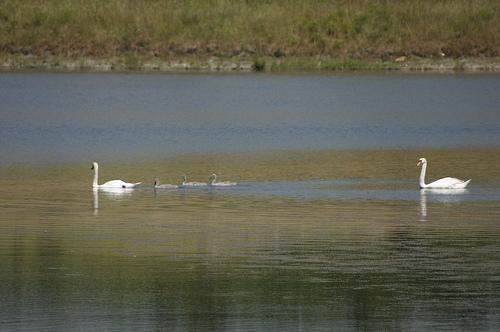In a simple sentence, describe the main event in the image. The image shows a family of swans swimming together in a tranquil lake. What are the main colors and objects present in the image? The dominant colors in the image are blue and white, featuring a swan swimming with its three gray babies on a calm lake. Discuss the primary subject of the image and the environment they inhabit. A swan family, consisting of a mother and her three gray babies, glides gently on the calm blue lake water, with green grass by the water's edge. Report what you see happening in the image, focusing on the center of attention. In the image, we see a swan mother with her three babies moving gracefully on the water of a peaceful lake. Convey the main activity occurring in the image, paying attention to the key subjects. A swan with a long neck is swimming in the lake, accompanied by its three gray baby swans in a row. Provide a brief description of the prominent elements in the image. The image captures a swan family swimming in the water, with reflections and ripples around them, and greenery near the bank of the pond. Illustrate the central focus and its surroundings in the image. The image shows a white swan leading its three babies in the water, with the bank of the pond and nearby greenery in the background. Mention the key figures in the image and what they're involved in. Five white swans, including one mother and three small ones, are swimming happily in the calm lake water. Identify the primary focus of the image and explain the action taking place. A swan on the water, accompanied by three baby swans, is swimming gracefully on a calm, blue lake. Describe the scene taking place in the image. A swan and its three gray babies are swimming together in a serene lake, rippling the water and casting reflections as they go. 